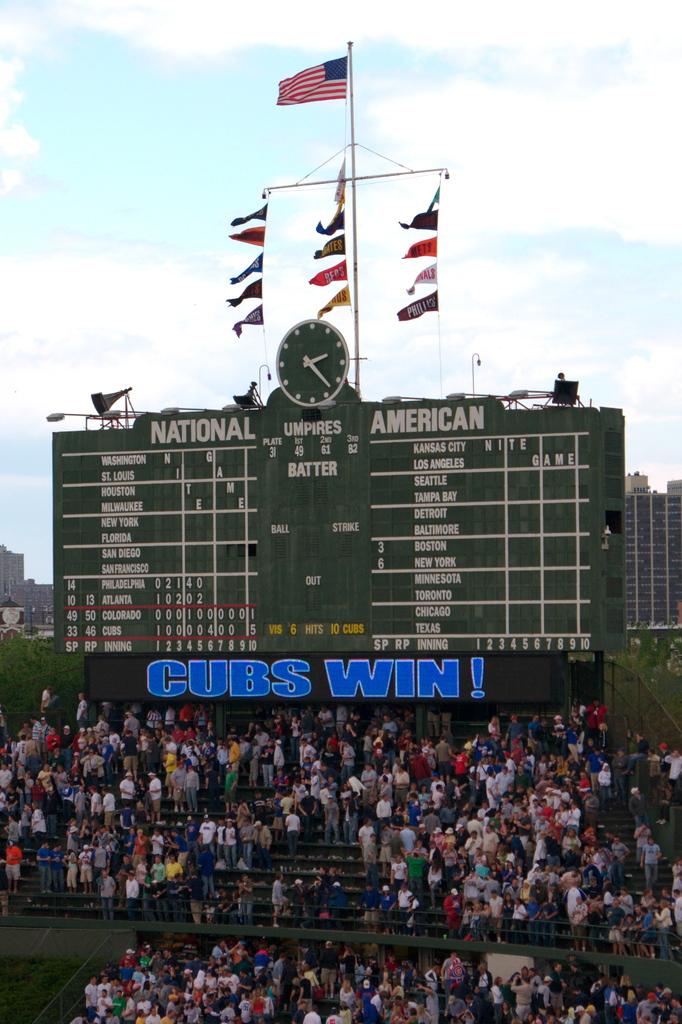Who won the game?
Your answer should be very brief. Cubs. What are the two large words on either side of the clock?
Offer a very short reply. National american. 